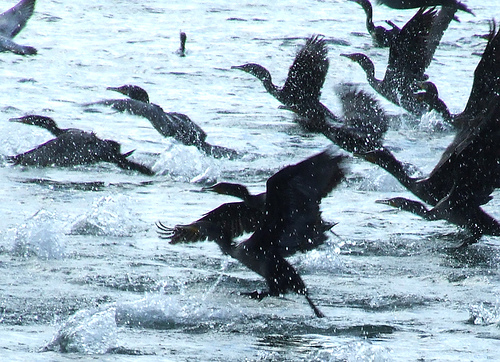Please provide the bounding box coordinate of the region this sentence describes: water drops over bird. The bounding box coordinates for the area where 'water drops over bird' are visible are [0.02, 0.31, 0.3, 0.54]. This region captures the interaction of the water droplets as they fall onto the bird. 